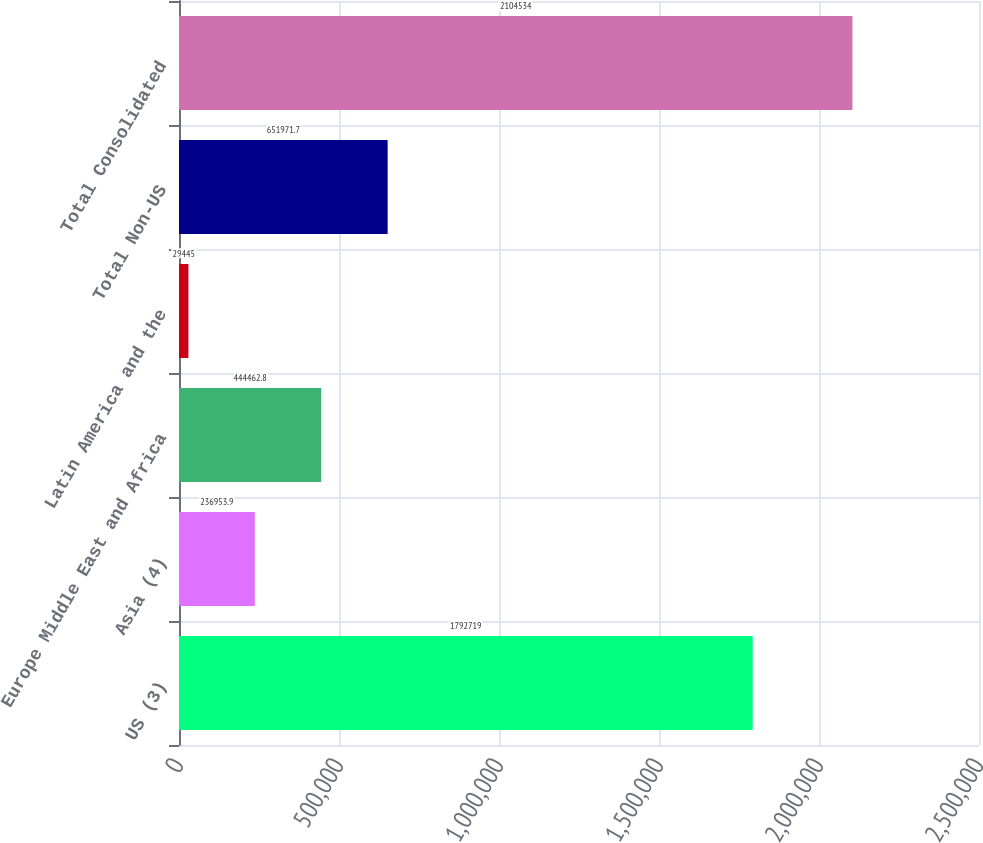Convert chart to OTSL. <chart><loc_0><loc_0><loc_500><loc_500><bar_chart><fcel>US (3)<fcel>Asia (4)<fcel>Europe Middle East and Africa<fcel>Latin America and the<fcel>Total Non-US<fcel>Total Consolidated<nl><fcel>1.79272e+06<fcel>236954<fcel>444463<fcel>29445<fcel>651972<fcel>2.10453e+06<nl></chart> 